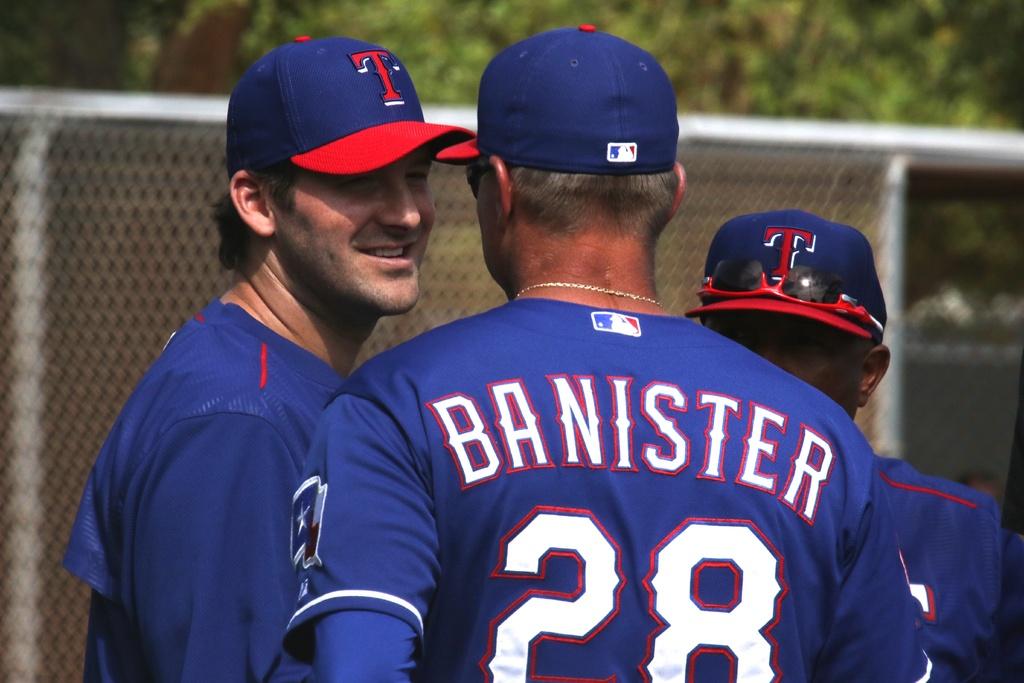Is banister the name of the player with number 28 on his shirt?
Keep it short and to the point. Yes. 